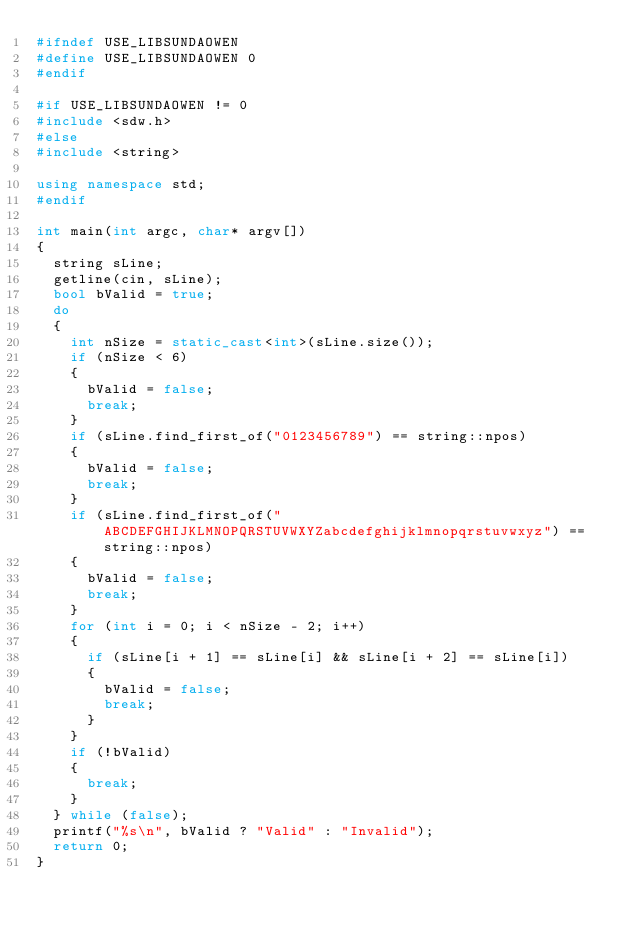<code> <loc_0><loc_0><loc_500><loc_500><_C++_>#ifndef USE_LIBSUNDAOWEN
#define USE_LIBSUNDAOWEN 0
#endif

#if USE_LIBSUNDAOWEN != 0
#include <sdw.h>
#else
#include <string>

using namespace std;
#endif

int main(int argc, char* argv[])
{
	string sLine;
	getline(cin, sLine);
	bool bValid = true;
	do
	{
		int nSize = static_cast<int>(sLine.size());
		if (nSize < 6)
		{
			bValid = false;
			break;
		}
		if (sLine.find_first_of("0123456789") == string::npos)
		{
			bValid = false;
			break;
		}
		if (sLine.find_first_of("ABCDEFGHIJKLMNOPQRSTUVWXYZabcdefghijklmnopqrstuvwxyz") == string::npos)
		{
			bValid = false;
			break;
		}
		for (int i = 0; i < nSize - 2; i++)
		{
			if (sLine[i + 1] == sLine[i] && sLine[i + 2] == sLine[i])
			{
				bValid = false;
				break;
			}
		}
		if (!bValid)
		{
			break;
		}
	} while (false);
	printf("%s\n", bValid ? "Valid" : "Invalid");
	return 0;
}
</code> 